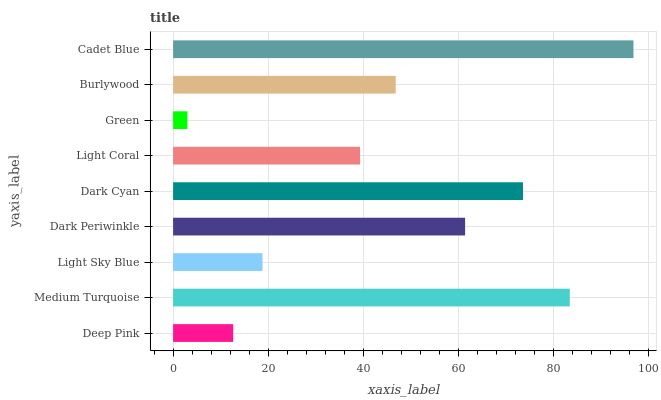Is Green the minimum?
Answer yes or no. Yes. Is Cadet Blue the maximum?
Answer yes or no. Yes. Is Medium Turquoise the minimum?
Answer yes or no. No. Is Medium Turquoise the maximum?
Answer yes or no. No. Is Medium Turquoise greater than Deep Pink?
Answer yes or no. Yes. Is Deep Pink less than Medium Turquoise?
Answer yes or no. Yes. Is Deep Pink greater than Medium Turquoise?
Answer yes or no. No. Is Medium Turquoise less than Deep Pink?
Answer yes or no. No. Is Burlywood the high median?
Answer yes or no. Yes. Is Burlywood the low median?
Answer yes or no. Yes. Is Cadet Blue the high median?
Answer yes or no. No. Is Light Coral the low median?
Answer yes or no. No. 